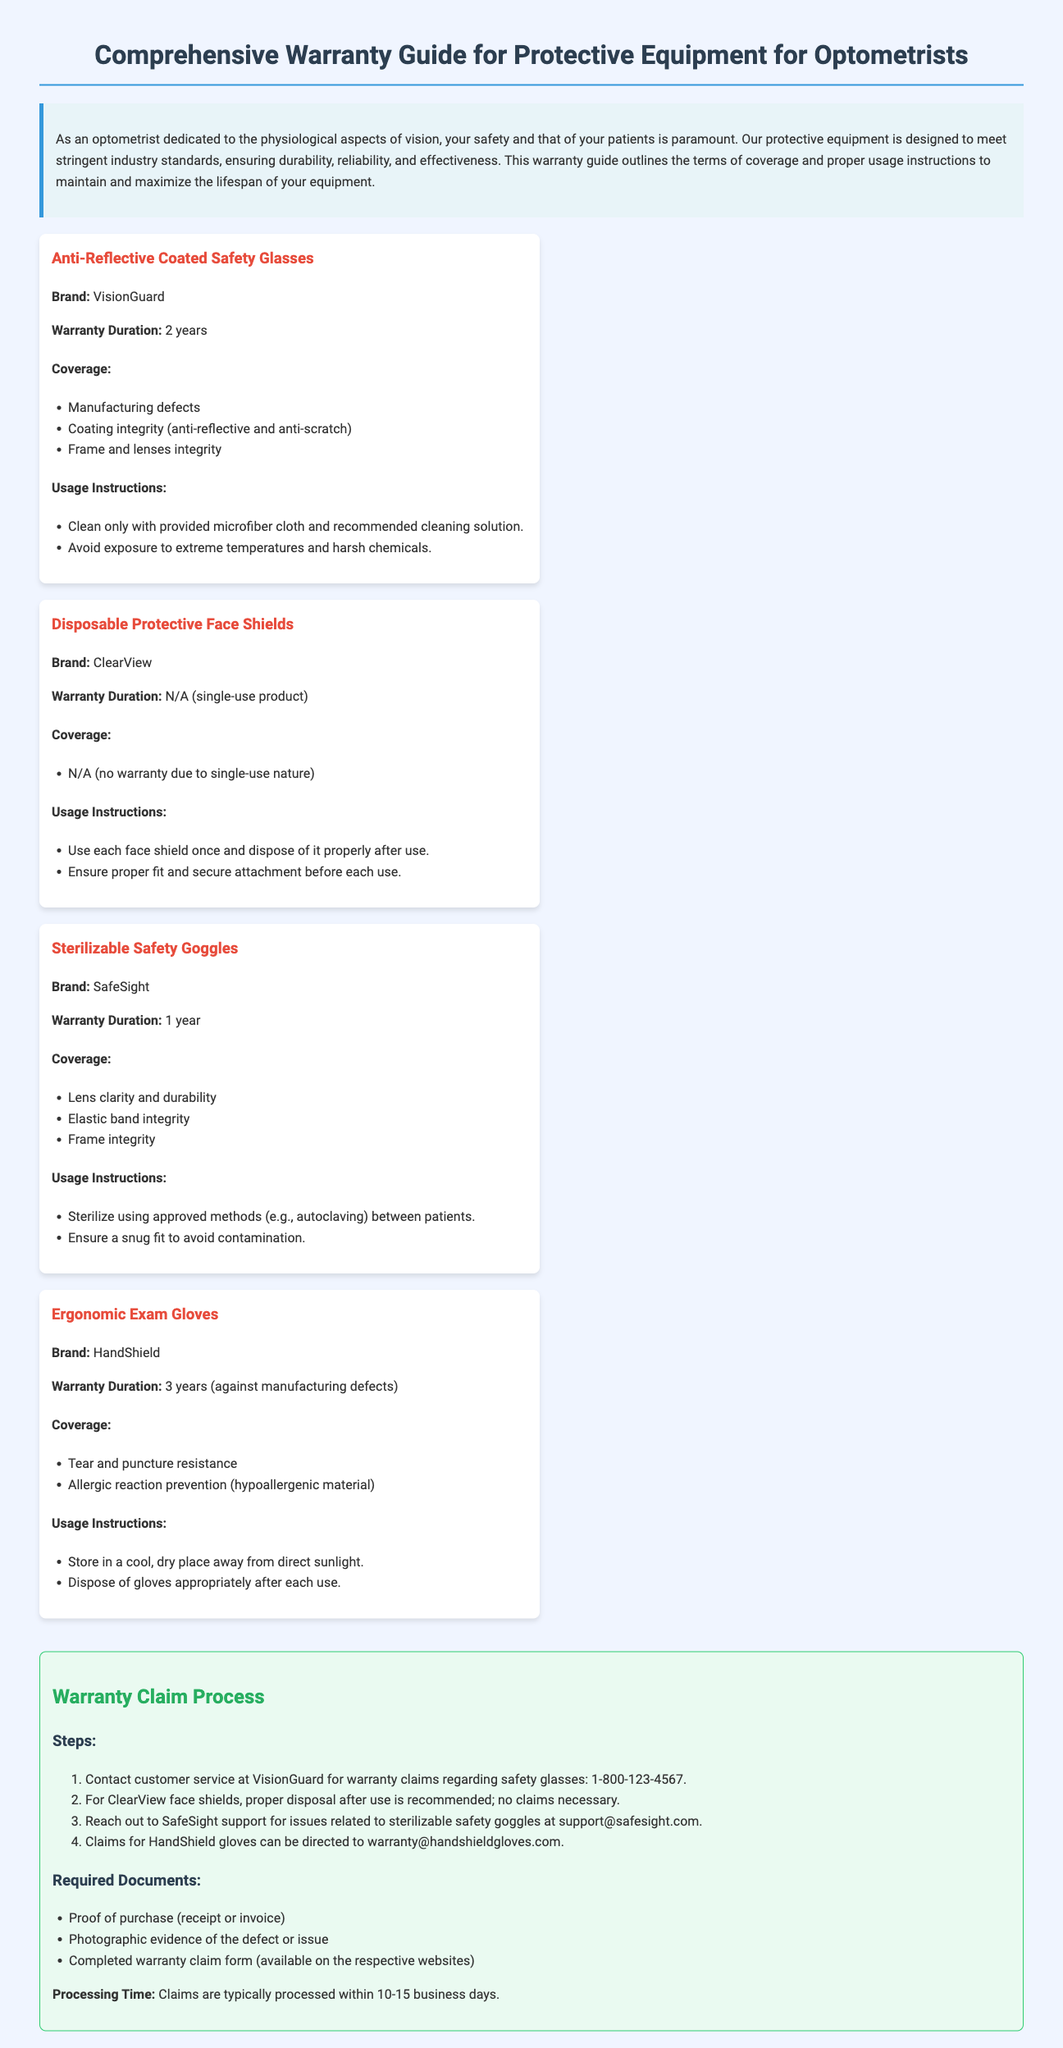What is the warranty duration for Anti-Reflective Coated Safety Glasses? The warranty duration is clearly specified in the document for each equipment; for Anti-Reflective Coated Safety Glasses, it is 2 years.
Answer: 2 years What is the brand of the Sterilizable Safety Goggles? The brand name is mentioned under each equipment section; the Sterilizable Safety Goggles are by SafeSight.
Answer: SafeSight What type of equipment does ClearView produce? The document lists types of equipment and their corresponding brands; ClearView produces Disposable Protective Face Shields.
Answer: Disposable Protective Face Shields How long is the warranty for Ergonomic Exam Gloves? The duration of the warranty is specifically stated in the document for Ergonomic Exam Gloves, which covers a period against manufacturing defects.
Answer: 3 years What is the primary usage instruction for Sterilizable Safety Goggles? The document outlines specific usage instructions for each type of equipment; for Sterilizable Safety Goggles, it is to sterilize using approved methods between patients.
Answer: Sterilize using approved methods between patients What is the processing time for warranty claims? The processing time is detailed in the claim process section of the document, indicating how long claims typically take to process.
Answer: 10-15 business days What should be provided as proof of purchase? The document specifies required documents for claims; one of the documents needed is proof of purchase, which can be a receipt or invoice.
Answer: Receipt or invoice Why is there no warranty for Disposable Protective Face Shields? The reason is provided in the coverage section of the face shields, stating it is a single-use product which does not come with warranty coverage.
Answer: N/A (no warranty due to single-use nature) 